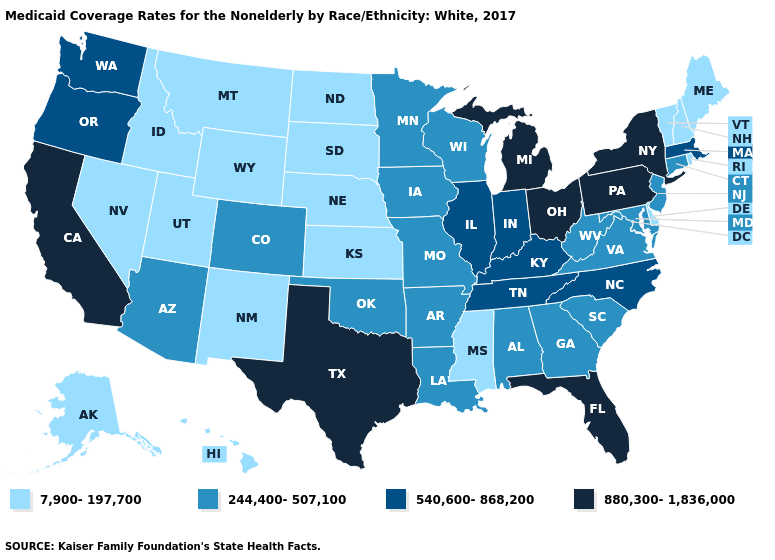Among the states that border New Hampshire , which have the lowest value?
Quick response, please. Maine, Vermont. Does California have a higher value than Florida?
Write a very short answer. No. Does New Jersey have the lowest value in the USA?
Concise answer only. No. Name the states that have a value in the range 540,600-868,200?
Quick response, please. Illinois, Indiana, Kentucky, Massachusetts, North Carolina, Oregon, Tennessee, Washington. Does the map have missing data?
Write a very short answer. No. Which states have the lowest value in the South?
Answer briefly. Delaware, Mississippi. Name the states that have a value in the range 540,600-868,200?
Give a very brief answer. Illinois, Indiana, Kentucky, Massachusetts, North Carolina, Oregon, Tennessee, Washington. What is the highest value in states that border Delaware?
Give a very brief answer. 880,300-1,836,000. Name the states that have a value in the range 7,900-197,700?
Write a very short answer. Alaska, Delaware, Hawaii, Idaho, Kansas, Maine, Mississippi, Montana, Nebraska, Nevada, New Hampshire, New Mexico, North Dakota, Rhode Island, South Dakota, Utah, Vermont, Wyoming. Which states hav the highest value in the West?
Answer briefly. California. What is the highest value in states that border Oregon?
Keep it brief. 880,300-1,836,000. Does Hawaii have the lowest value in the USA?
Answer briefly. Yes. Does South Dakota have the same value as West Virginia?
Write a very short answer. No. Name the states that have a value in the range 540,600-868,200?
Write a very short answer. Illinois, Indiana, Kentucky, Massachusetts, North Carolina, Oregon, Tennessee, Washington. Does Mississippi have the lowest value in the South?
Be succinct. Yes. 